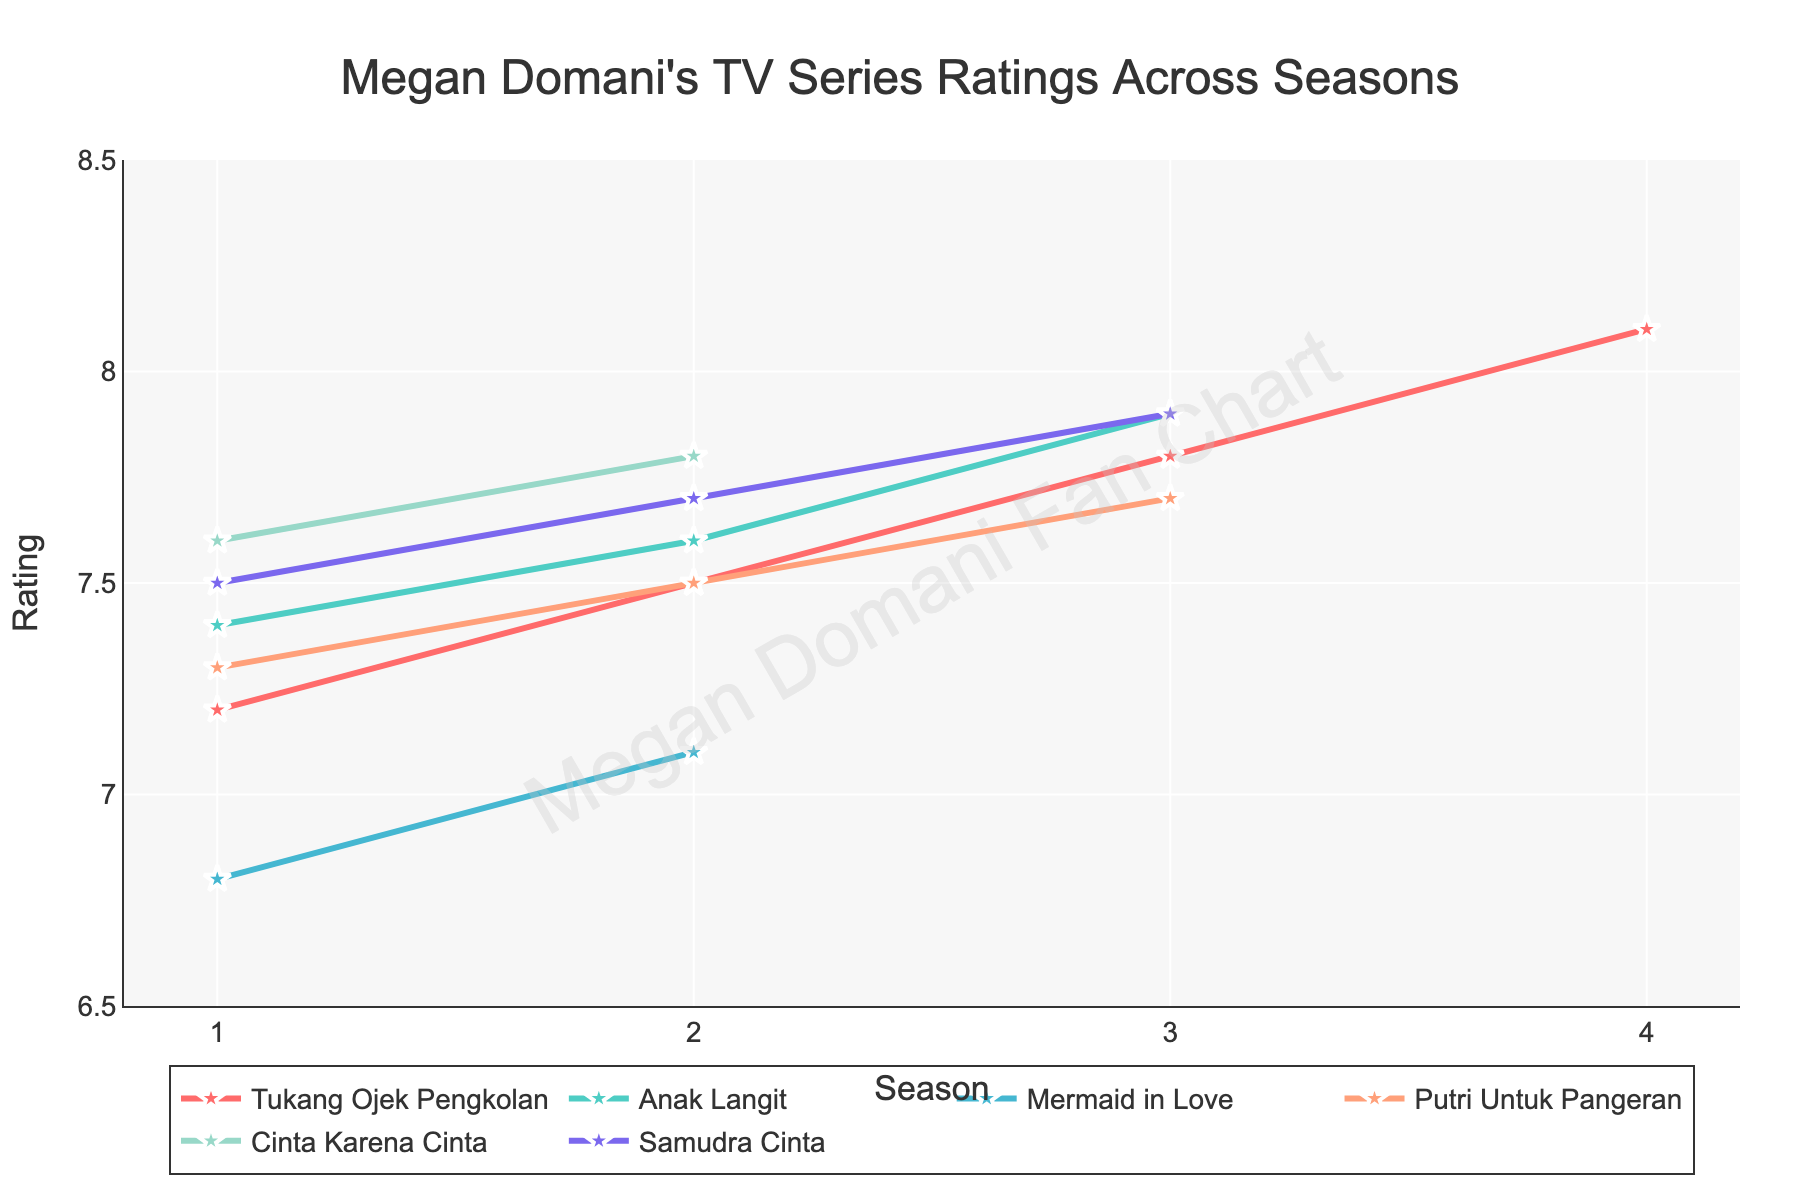What trend is observable in the ratings of 'Tukang Ojek Pengkolan' over the seasons? By looking at the plot, we can see that the ratings of 'Tukang Ojek Pengkolan' increase steadily from Season 1 to Season 4. Each subsequent season has a higher rating than the previous one.
Answer: Increasing trend Which TV series has the lowest rating in any season, and what is that rating? The lowest rating in any season is for 'Mermaid in Love' in Season 1 with a rating of 6.8. This can be identified by locating the lowest point in the chart.
Answer: 'Mermaid in Love', 6.8 How does the rating change from Season 1 to Season 3 for 'Anak Langit'? By examining the line for 'Anak Langit', we see that the rating increases from 7.4 in Season 1 to 7.6 in Season 2, and further to 7.9 in Season 3. There is a steady increase in ratings across the three seasons.
Answer: Increases from 7.4 to 7.9 What is the average rating of 'Samudra Cinta' across all its seasons? To find the average rating, sum up the ratings for each season and divide by the number of seasons. The ratings are 7.5, 7.7, and 7.9. (7.5 + 7.7 + 7.9) / 3 = 23.1 / 3 = 7.7.
Answer: 7.7 Which series has the highest rating in its final season, and what is that rating? The highest rating in the final seasons can be identified by comparing the endpoints of each line. 'Tukang Ojek Pengkolan' in Season 4 has the highest final season rating of 8.1.
Answer: 'Tukang Ojek Pengkolan', 8.1 Between 'Putri Untuk Pangeran' and 'Cinta Karena Cinta', which series has a higher rating in their first season? By locating the first season points for both series, 'Cinta Karena Cinta' has a higher rating of 7.6 compared to 'Putri Untuk Pangeran' which has a rating of 7.3.
Answer: 'Cinta Karena Cinta', 7.6 Compare the rating of 'Mermaid in Love' in Season 1 and Season 2. What is the difference in rating? 'Mermaid in Love' has ratings of 6.8 in Season 1 and 7.1 in Season 2. The difference is 7.1 - 6.8 = 0.3.
Answer: 0.3 What is the highest rating observed across all TV series and seasons? The highest rating can be observed by finding the peak point in the chart. The highest rating is 8.1, which 'Tukang Ojek Pengkolan' achieved in Season 4.
Answer: 8.1 Identify the color used for the 'Samudra Cinta' series in the plot. The 'Samudra Cinta' series is represented by the purple line in the plot. The color purple is used to distinguish it from other series.
Answer: Purple 